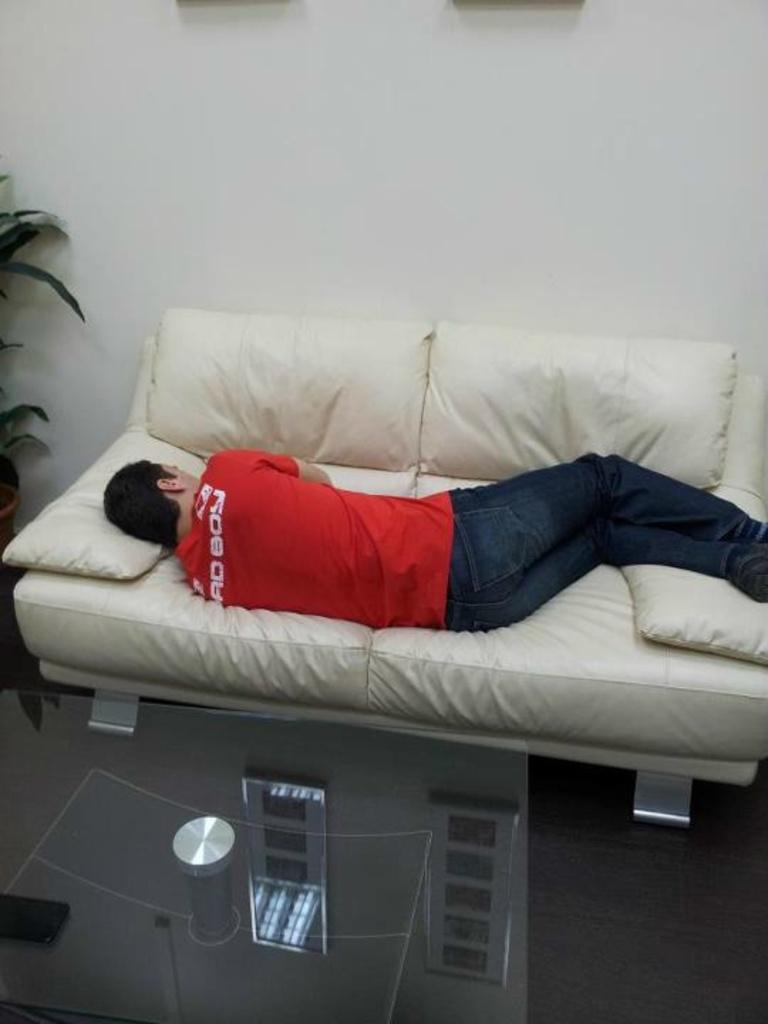What is the man doing in the image? The man is sleeping on a white couch. What is in front of the man? There is a table in front of the man. What can be seen on the table? The table has a reflection of windows. What is located beside the couch? There is a plant beside the couch. What type of sand can be seen on the plant in the image? There is no sand present in the image, and the plant does not have any sand on it. 